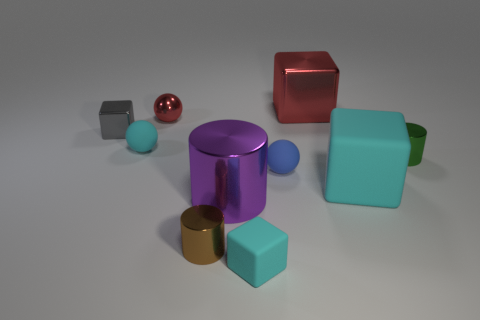Is the number of cyan rubber blocks that are to the left of the green cylinder greater than the number of large purple objects?
Keep it short and to the point. Yes. How many objects are small red cubes or metal objects that are to the right of the large cyan thing?
Your answer should be compact. 1. Are there more cubes that are behind the green metal cylinder than metal spheres that are behind the large red shiny object?
Make the answer very short. Yes. What material is the small cube in front of the blue object that is on the right side of the shiny cube to the left of the large purple object?
Offer a very short reply. Rubber. What is the shape of the large red thing that is the same material as the purple thing?
Your answer should be very brief. Cube. Are there any matte blocks that are to the right of the small cyan object behind the big purple cylinder?
Offer a terse response. Yes. What size is the green metallic cylinder?
Provide a short and direct response. Small. What number of things are either large purple metal cylinders or rubber blocks?
Your answer should be compact. 3. Is the ball that is to the left of the small red metallic ball made of the same material as the red block behind the tiny green cylinder?
Provide a succinct answer. No. What color is the large cube that is the same material as the large purple cylinder?
Offer a terse response. Red. 